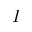<formula> <loc_0><loc_0><loc_500><loc_500>I</formula> 